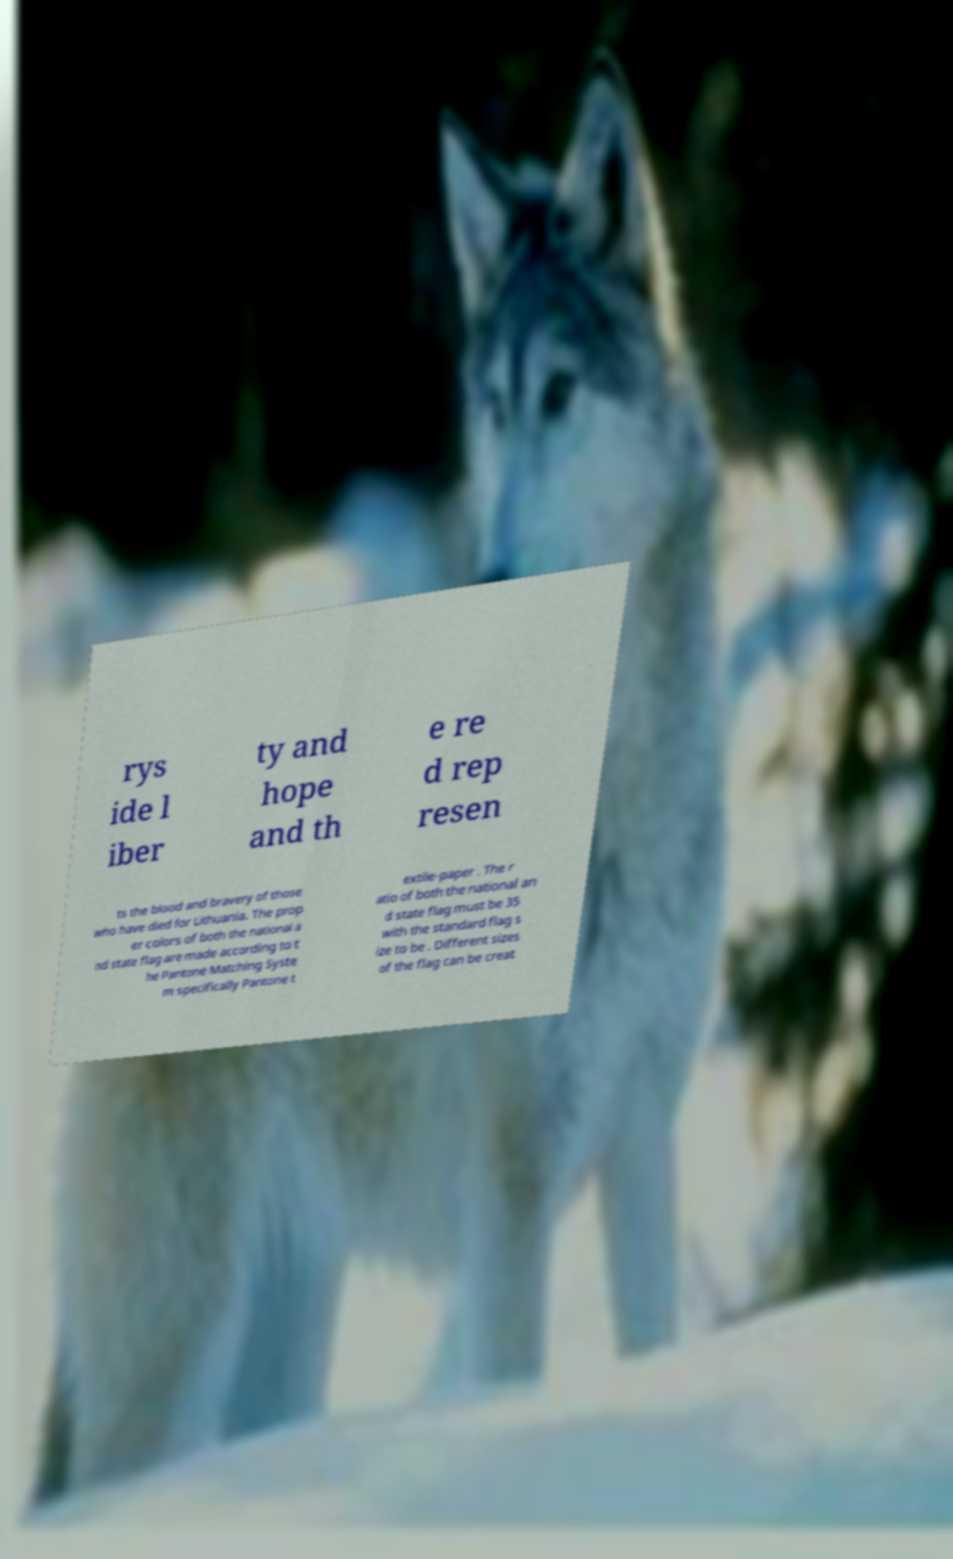Please read and relay the text visible in this image. What does it say? rys ide l iber ty and hope and th e re d rep resen ts the blood and bravery of those who have died for Lithuania. The prop er colors of both the national a nd state flag are made according to t he Pantone Matching Syste m specifically Pantone t extile-paper . The r atio of both the national an d state flag must be 35 with the standard flag s ize to be . Different sizes of the flag can be creat 